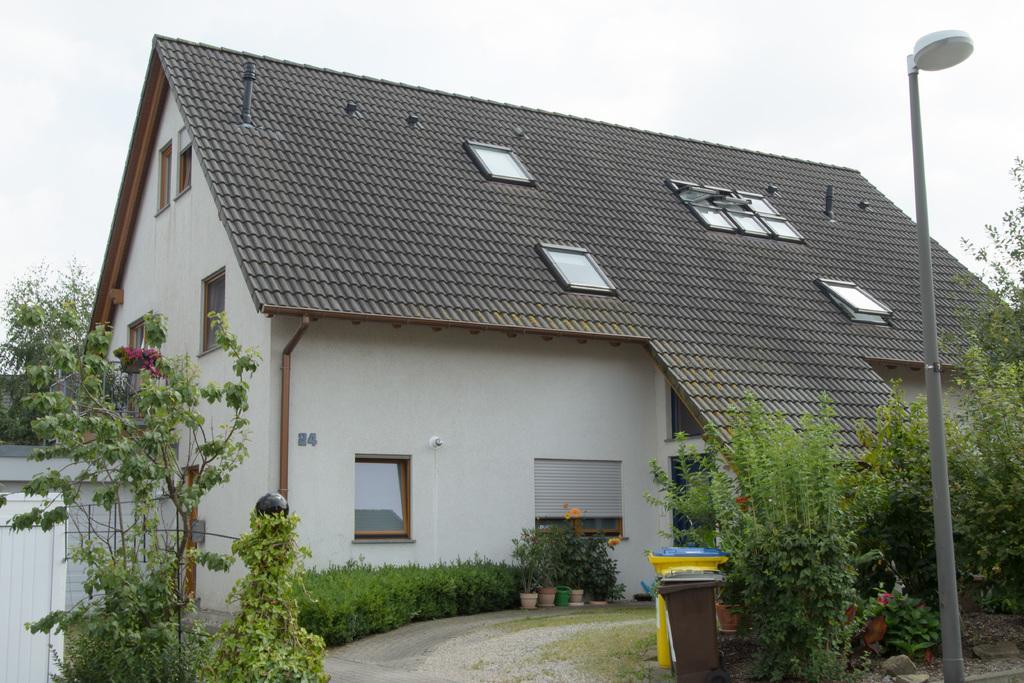How would you summarize this image in a sentence or two? This is the picture of a place where we have a house to which there are some windows and around there are some plants, trees, some other things and a pole which has a lamp. 